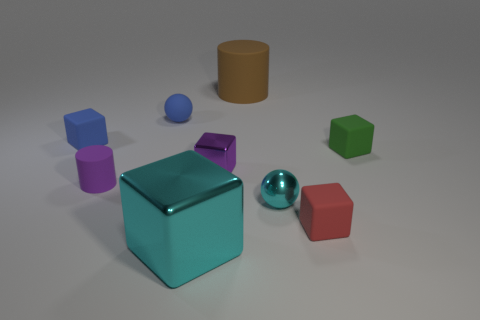The sphere that is made of the same material as the large cyan cube is what size?
Provide a short and direct response. Small. What number of things are small rubber things in front of the small cyan metallic thing or matte things that are behind the small cyan thing?
Provide a short and direct response. 6. Is the number of small cubes left of the tiny cylinder the same as the number of big brown cylinders that are in front of the small cyan metallic object?
Make the answer very short. No. What color is the rubber cylinder on the left side of the big block?
Ensure brevity in your answer.  Purple. There is a big matte object; is its color the same as the large thing in front of the small blue rubber block?
Your response must be concise. No. Are there fewer yellow metallic cubes than cyan metallic cubes?
Offer a very short reply. Yes. Does the tiny metal thing on the left side of the large brown cylinder have the same color as the big block?
Your answer should be very brief. No. What number of rubber things have the same size as the cyan cube?
Offer a terse response. 1. Is there another matte ball that has the same color as the rubber ball?
Give a very brief answer. No. Is the tiny red thing made of the same material as the small blue ball?
Provide a succinct answer. Yes. 